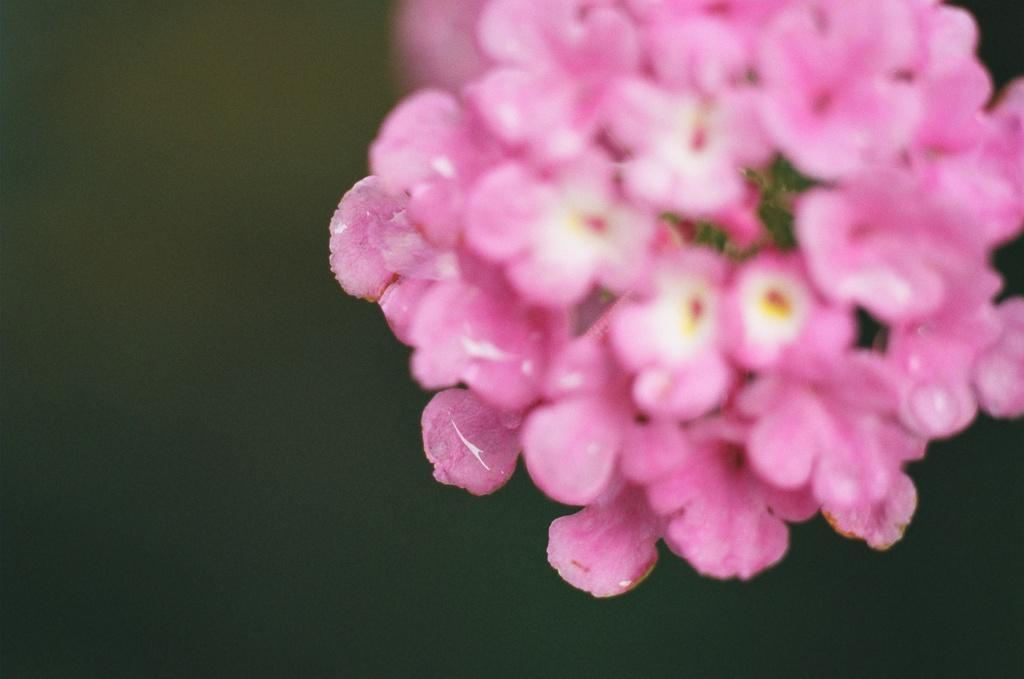What type of flowers can be seen in the image? There are pink flowers in the image. Can you describe the background of the image? The background of the image is blurred. What type of knowledge is being shared in the image? There is no indication of knowledge being shared in the image; it primarily features pink flowers. 